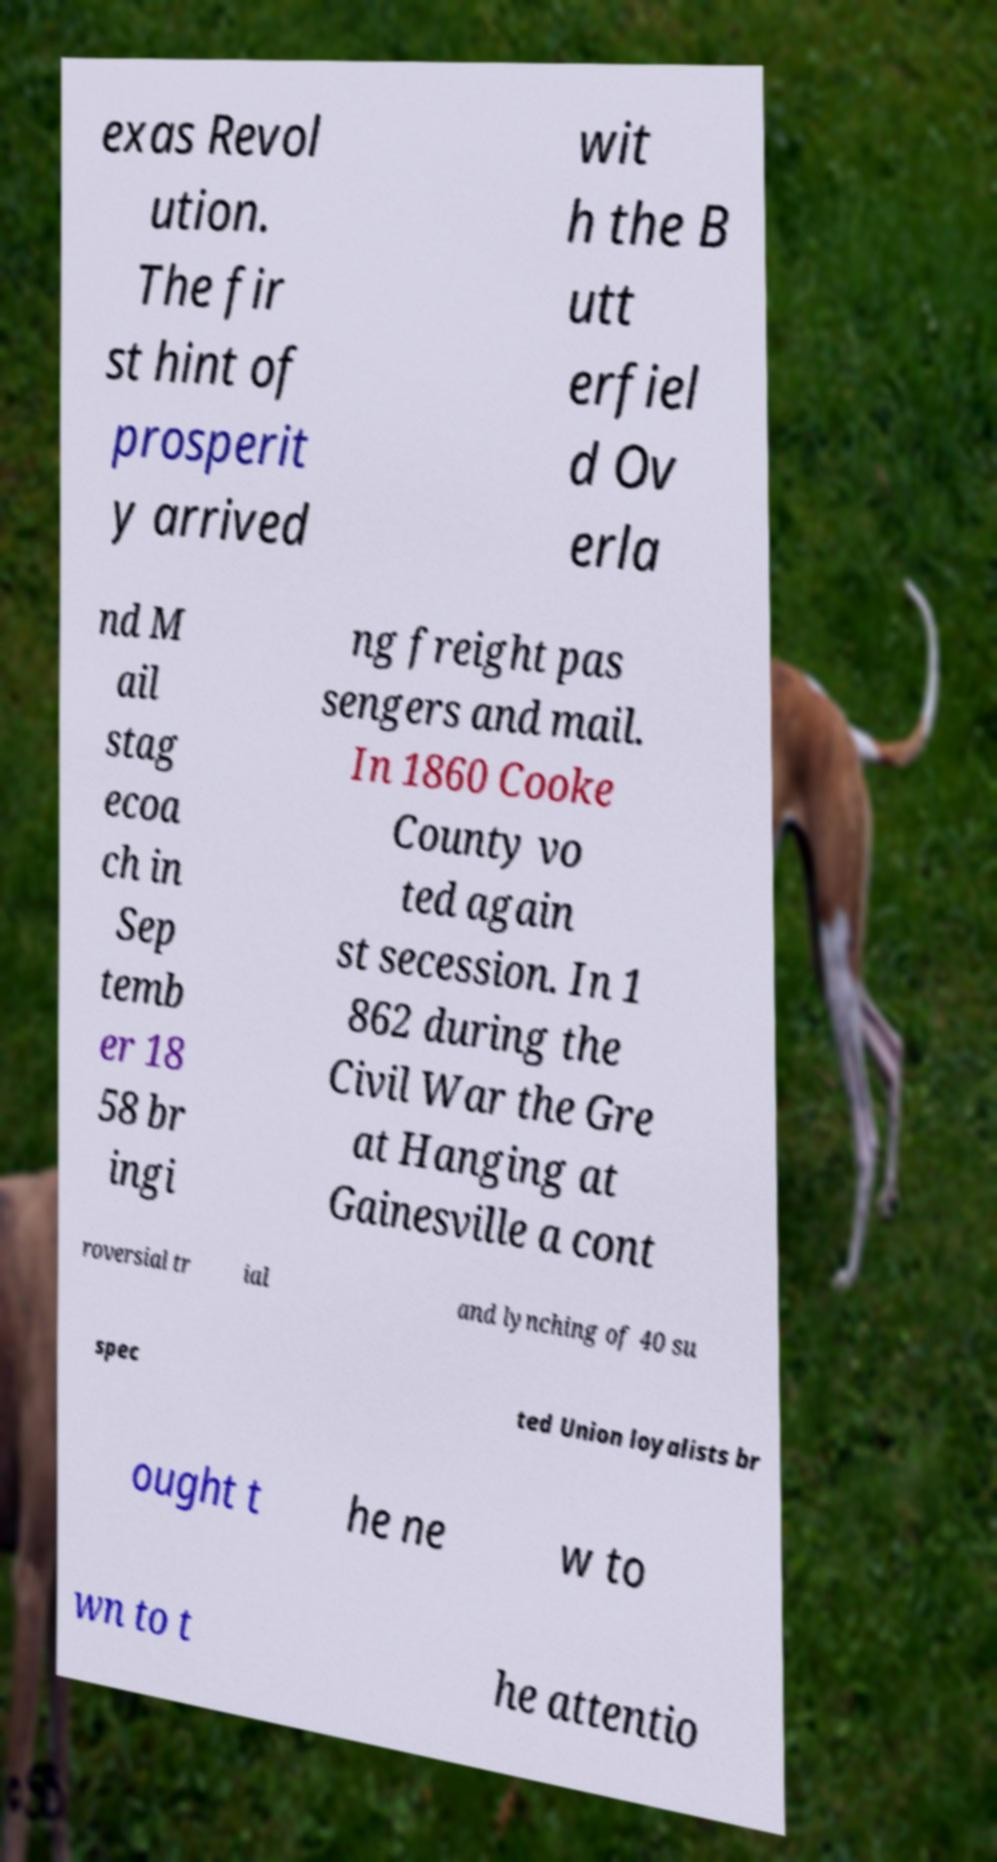I need the written content from this picture converted into text. Can you do that? exas Revol ution. The fir st hint of prosperit y arrived wit h the B utt erfiel d Ov erla nd M ail stag ecoa ch in Sep temb er 18 58 br ingi ng freight pas sengers and mail. In 1860 Cooke County vo ted again st secession. In 1 862 during the Civil War the Gre at Hanging at Gainesville a cont roversial tr ial and lynching of 40 su spec ted Union loyalists br ought t he ne w to wn to t he attentio 